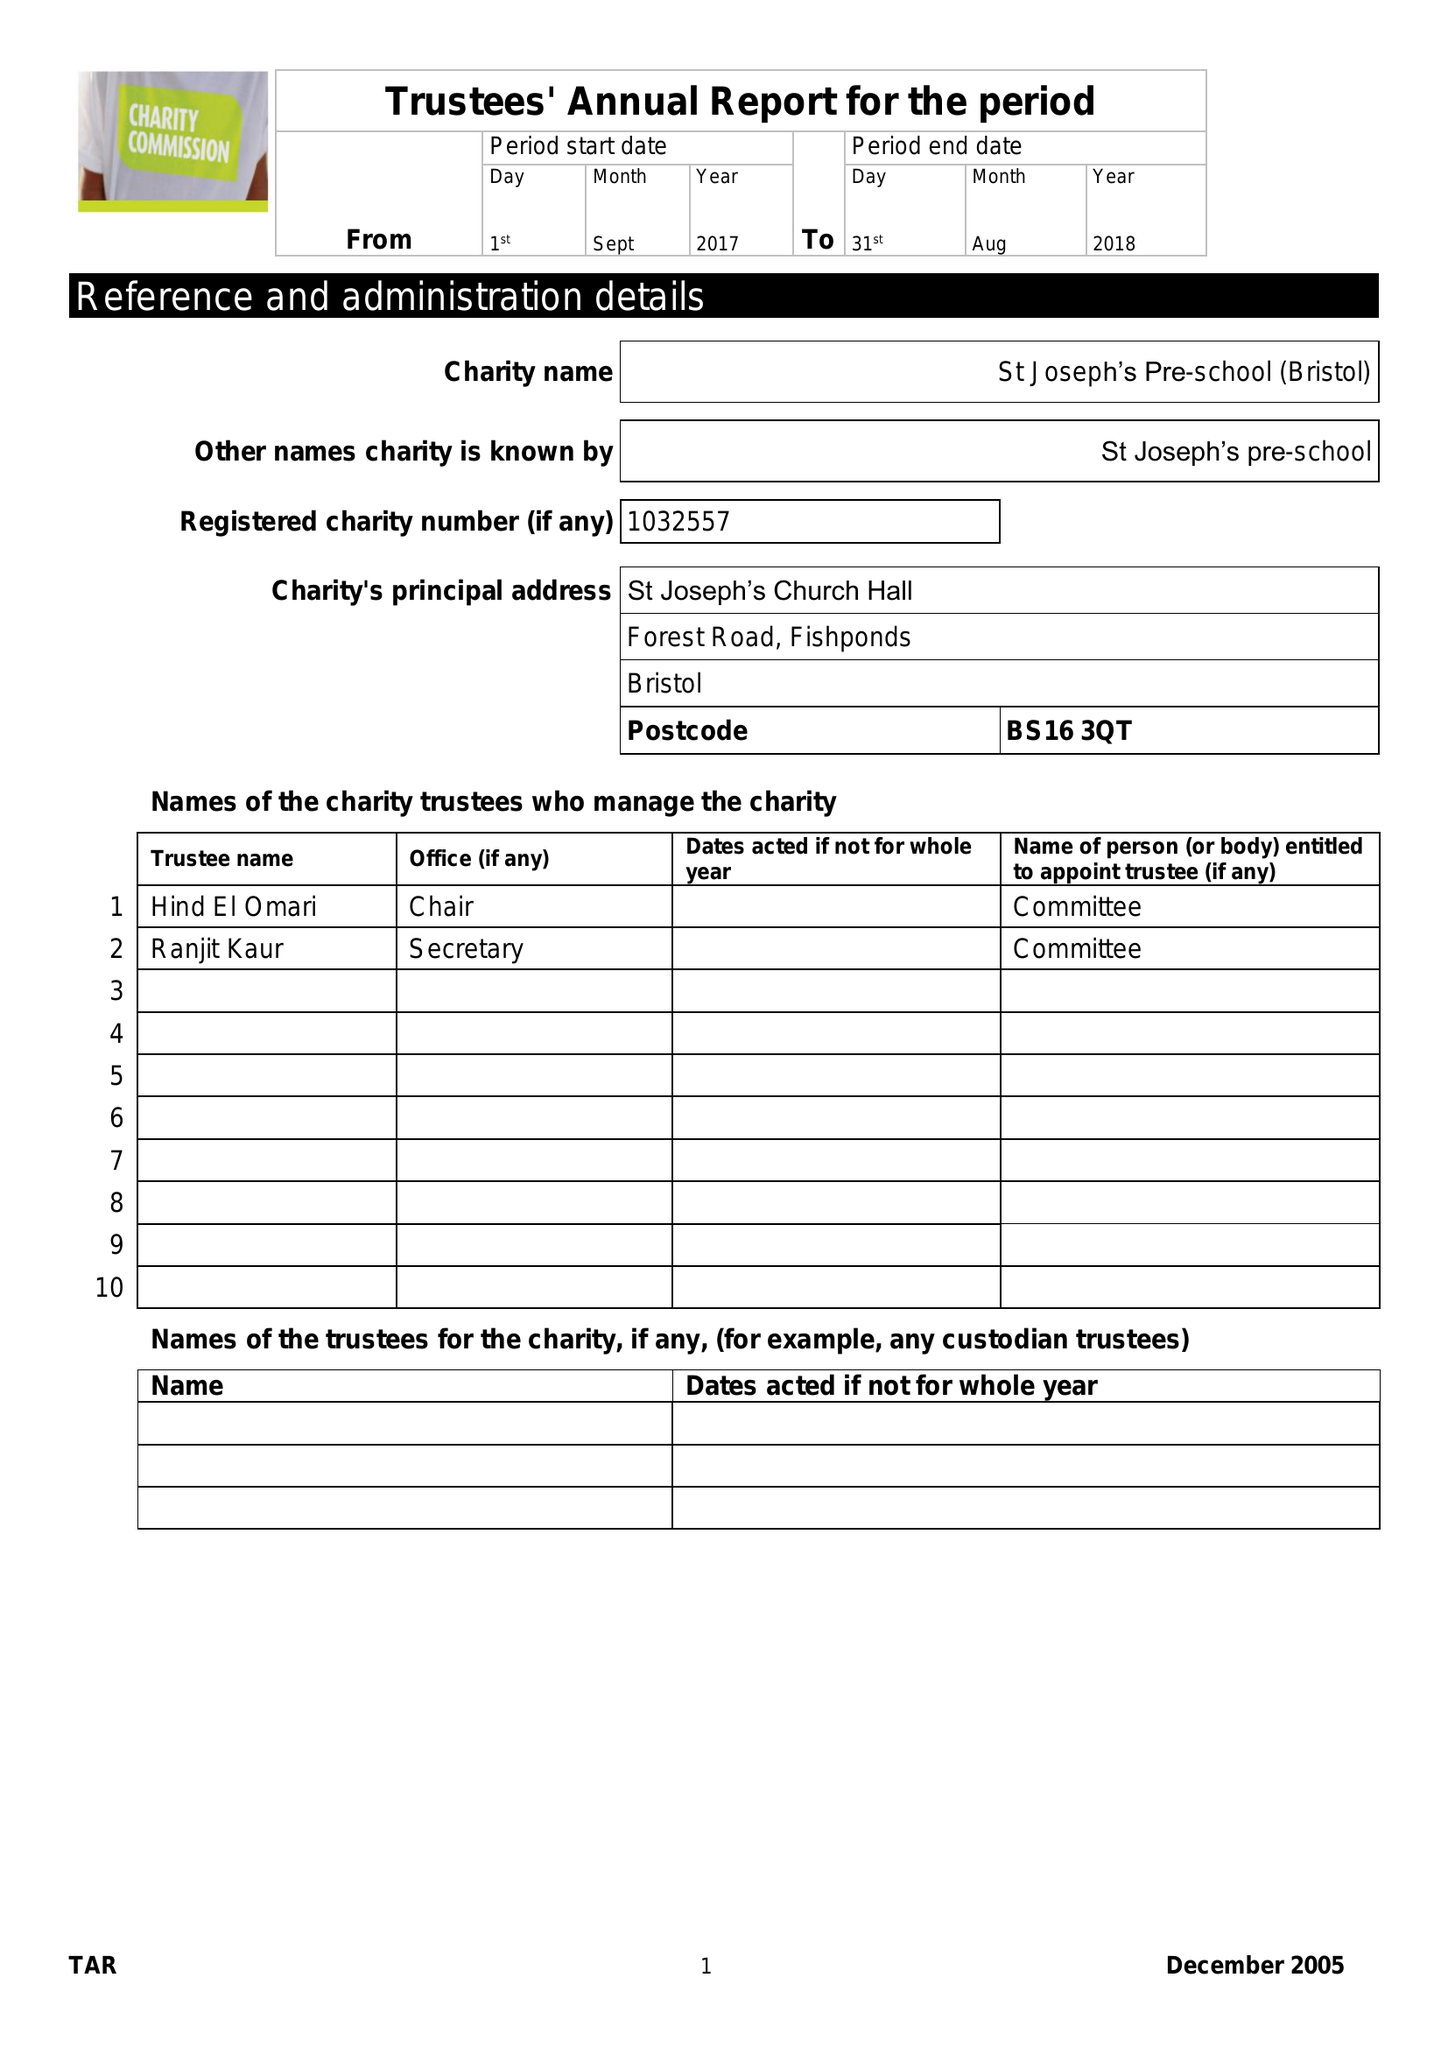What is the value for the spending_annually_in_british_pounds?
Answer the question using a single word or phrase. 199597.00 